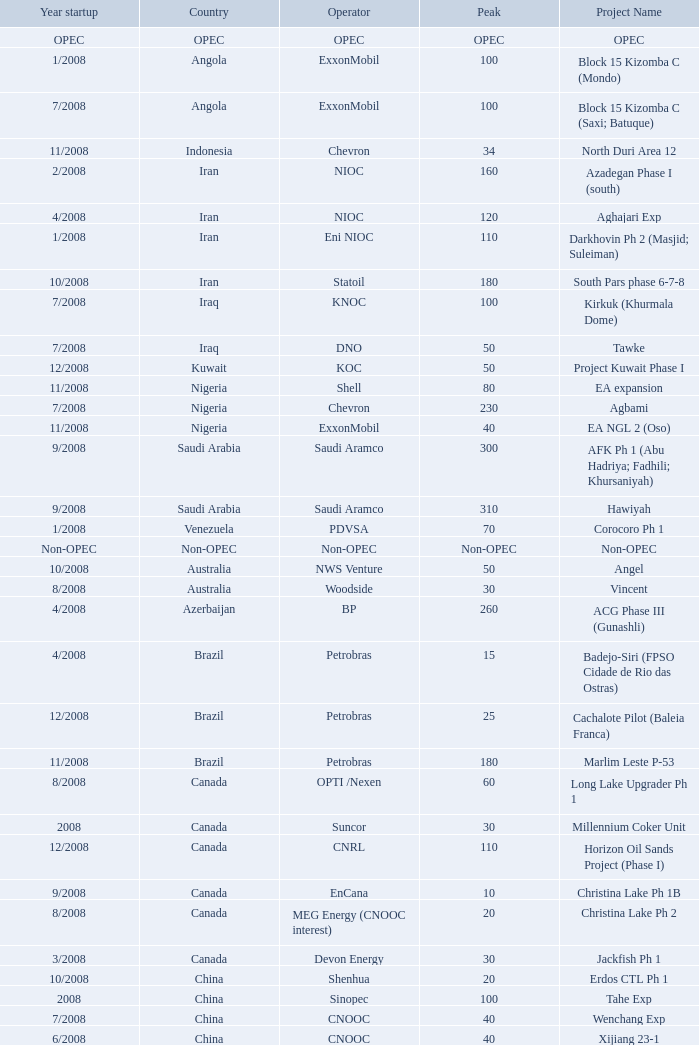What is the Project Name with a Country that is opec? OPEC. Write the full table. {'header': ['Year startup', 'Country', 'Operator', 'Peak', 'Project Name'], 'rows': [['OPEC', 'OPEC', 'OPEC', 'OPEC', 'OPEC'], ['1/2008', 'Angola', 'ExxonMobil', '100', 'Block 15 Kizomba C (Mondo)'], ['7/2008', 'Angola', 'ExxonMobil', '100', 'Block 15 Kizomba C (Saxi; Batuque)'], ['11/2008', 'Indonesia', 'Chevron', '34', 'North Duri Area 12'], ['2/2008', 'Iran', 'NIOC', '160', 'Azadegan Phase I (south)'], ['4/2008', 'Iran', 'NIOC', '120', 'Aghajari Exp'], ['1/2008', 'Iran', 'Eni NIOC', '110', 'Darkhovin Ph 2 (Masjid; Suleiman)'], ['10/2008', 'Iran', 'Statoil', '180', 'South Pars phase 6-7-8'], ['7/2008', 'Iraq', 'KNOC', '100', 'Kirkuk (Khurmala Dome)'], ['7/2008', 'Iraq', 'DNO', '50', 'Tawke'], ['12/2008', 'Kuwait', 'KOC', '50', 'Project Kuwait Phase I'], ['11/2008', 'Nigeria', 'Shell', '80', 'EA expansion'], ['7/2008', 'Nigeria', 'Chevron', '230', 'Agbami'], ['11/2008', 'Nigeria', 'ExxonMobil', '40', 'EA NGL 2 (Oso)'], ['9/2008', 'Saudi Arabia', 'Saudi Aramco', '300', 'AFK Ph 1 (Abu Hadriya; Fadhili; Khursaniyah)'], ['9/2008', 'Saudi Arabia', 'Saudi Aramco', '310', 'Hawiyah'], ['1/2008', 'Venezuela', 'PDVSA', '70', 'Corocoro Ph 1'], ['Non-OPEC', 'Non-OPEC', 'Non-OPEC', 'Non-OPEC', 'Non-OPEC'], ['10/2008', 'Australia', 'NWS Venture', '50', 'Angel'], ['8/2008', 'Australia', 'Woodside', '30', 'Vincent'], ['4/2008', 'Azerbaijan', 'BP', '260', 'ACG Phase III (Gunashli)'], ['4/2008', 'Brazil', 'Petrobras', '15', 'Badejo-Siri (FPSO Cidade de Rio das Ostras)'], ['12/2008', 'Brazil', 'Petrobras', '25', 'Cachalote Pilot (Baleia Franca)'], ['11/2008', 'Brazil', 'Petrobras', '180', 'Marlim Leste P-53'], ['8/2008', 'Canada', 'OPTI /Nexen', '60', 'Long Lake Upgrader Ph 1'], ['2008', 'Canada', 'Suncor', '30', 'Millennium Coker Unit'], ['12/2008', 'Canada', 'CNRL', '110', 'Horizon Oil Sands Project (Phase I)'], ['9/2008', 'Canada', 'EnCana', '10', 'Christina Lake Ph 1B'], ['8/2008', 'Canada', 'MEG Energy (CNOOC interest)', '20', 'Christina Lake Ph 2'], ['3/2008', 'Canada', 'Devon Energy', '30', 'Jackfish Ph 1'], ['10/2008', 'China', 'Shenhua', '20', 'Erdos CTL Ph 1'], ['2008', 'China', 'Sinopec', '100', 'Tahe Exp'], ['7/2008', 'China', 'CNOOC', '40', 'Wenchang Exp'], ['6/2008', 'China', 'CNOOC', '40', 'Xijiang 23-1'], ['4/2008', 'Congo', 'Total', '90', 'Moho Bilondo'], ['3/2008', 'Egypt', 'BP', '40', 'Saqqara'], ['9/2008', 'India', 'Reliance', '40', 'MA field (KG-D6)'], ['3/2008', 'Kazakhstan', 'Maersk', '150', 'Dunga'], ['5/2008', 'Kazakhstan', 'Petrom', '10', 'Komsomolskoe'], ['2008', 'Mexico', 'PEMEX', '200', '( Chicontepec ) Exp 1'], ['5/2008', 'Mexico', 'PEMEX', '20', 'Antonio J Bermudez Exp'], ['5/2008', 'Mexico', 'PEMEX', '20', 'Bellota Chinchorro Exp'], ['2008', 'Mexico', 'PEMEX', '55', 'Ixtal Manik'], ['2008', 'Mexico', 'PEMEX', '15', 'Jujo Tecominoacan Exp'], ['6/2008', 'Norway', 'Marathon', '100', 'Alvheim; Volund; Vilje'], ['2/2008', 'Norway', 'StatoilHydro', '35', 'Volve'], ['2008', 'Oman', 'Occidental', '40', 'Mukhaizna EOR Ph 1'], ['10/2008', 'Philippines', 'GPC', '15', 'Galoc'], ['10/2008', 'Russia', 'Surgutneftegaz', '60', 'Talakan Ph 1'], ['10/2008', 'Russia', 'TNK-BP Rosneft', '20', 'Verkhnechonsk Ph 1 (early oil)'], ['8/2008', 'Russia', 'Lukoil ConocoPhillips', '75', 'Yuzhno-Khylchuyuskoye "YK" Ph 1'], ['8/2008', 'Thailand', 'Salamander', '10', 'Bualuang'], ['7/2008', 'UK', 'Conoco Phillips', '25', 'Britannia Satellites (Callanish; Brodgar)'], ['11/2008', 'USA', 'Chevron', '45', 'Blind Faith'], ['7/2008', 'USA', 'BHP Billiton', '25', 'Neptune'], ['6/2008', 'USA', 'Pioneer', '15', 'Oooguruk'], ['7/2008', 'USA', 'ConocoPhillips', '4', 'Qannik'], ['6/2008', 'USA', 'BP', '210', 'Thunder Horse'], ['1/2008', 'USA', 'Shell', '30', 'Ursa Princess Exp'], ['7/2008', 'Vietnam', 'HVJOC', '15', 'Ca Ngu Vang (Golden Tuna)'], ['10/2008', 'Vietnam', 'Cuu Long Joint', '40', 'Su Tu Vang'], ['12/2008', 'Vietnam', 'Talisman', '10', 'Song Doc']]} 